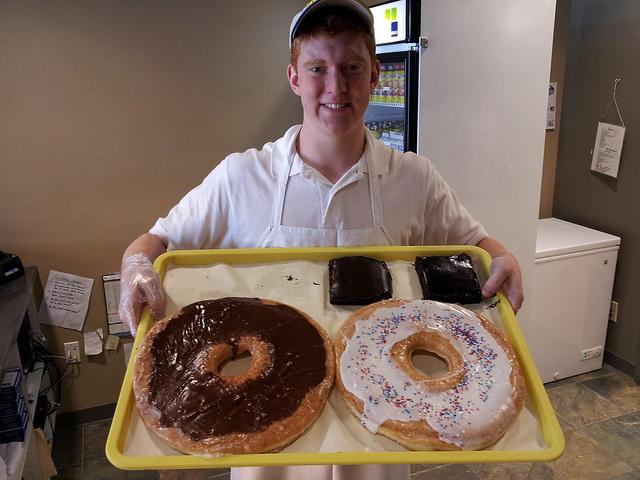Which hand decorated the donuts?
Give a very brief answer. Right. Are these normal sized donuts?
Concise answer only. No. Where is a deep freezer?
Quick response, please. Corner. 